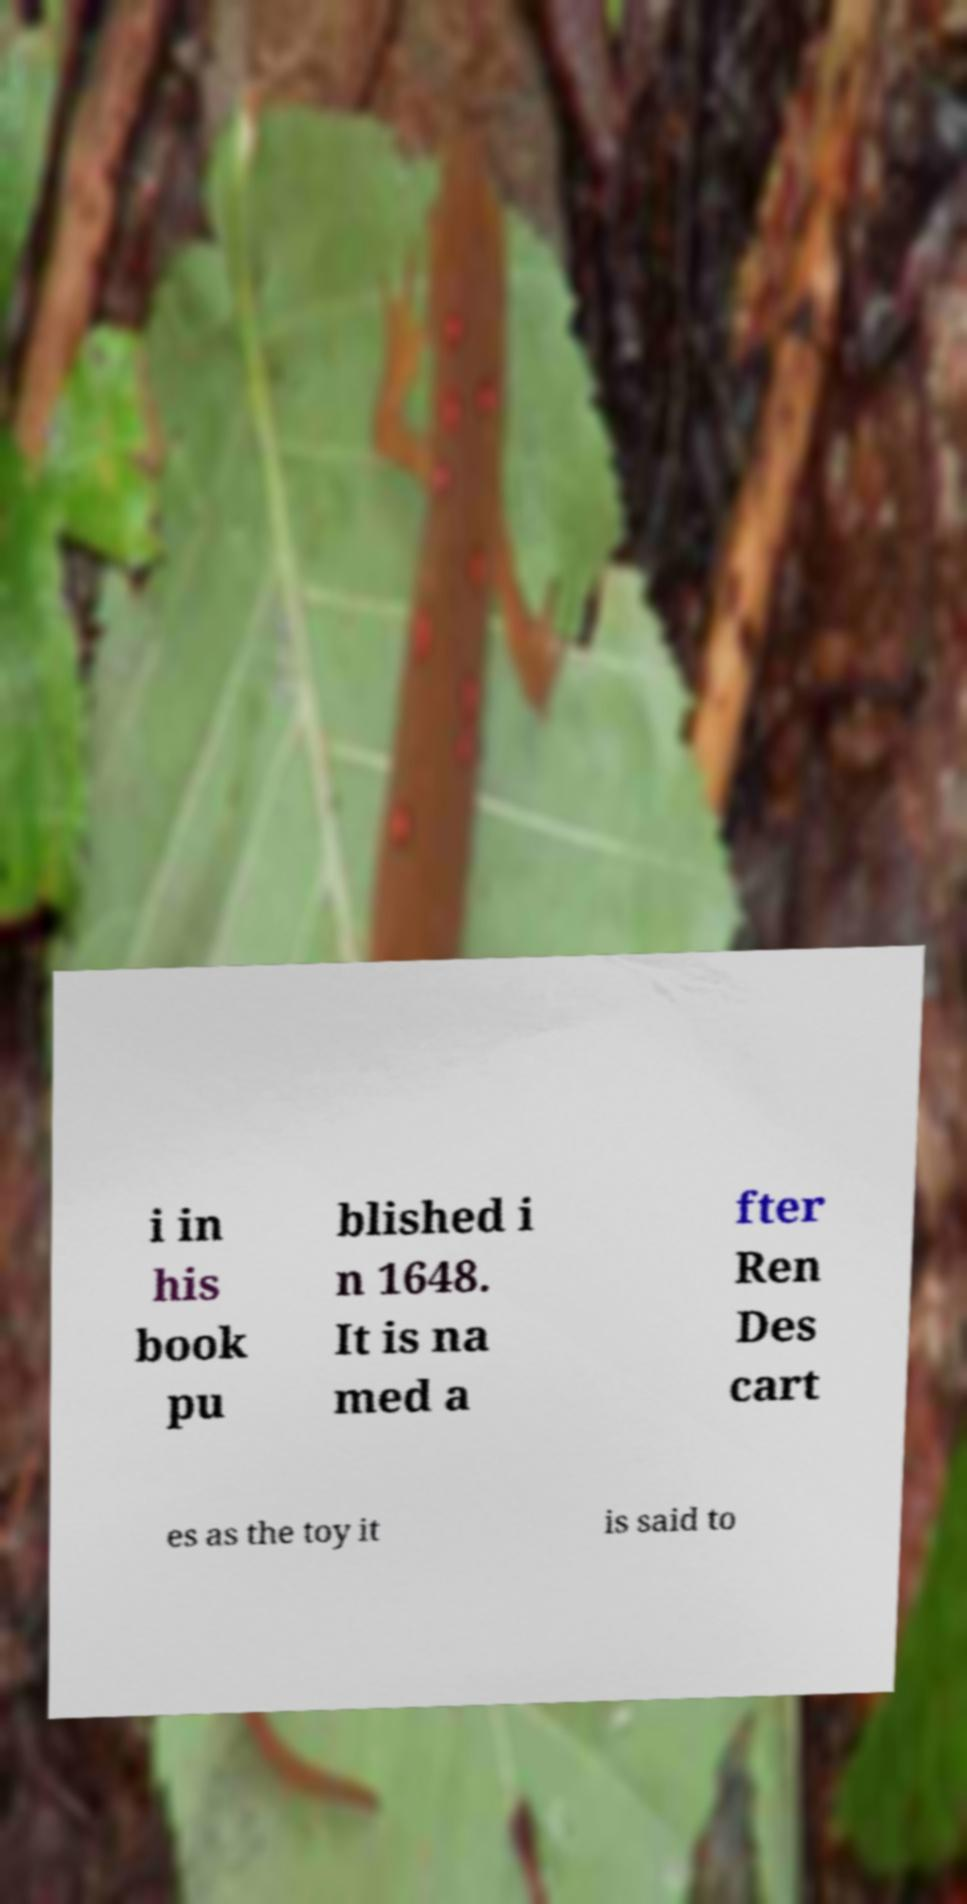Could you assist in decoding the text presented in this image and type it out clearly? i in his book pu blished i n 1648. It is na med a fter Ren Des cart es as the toy it is said to 